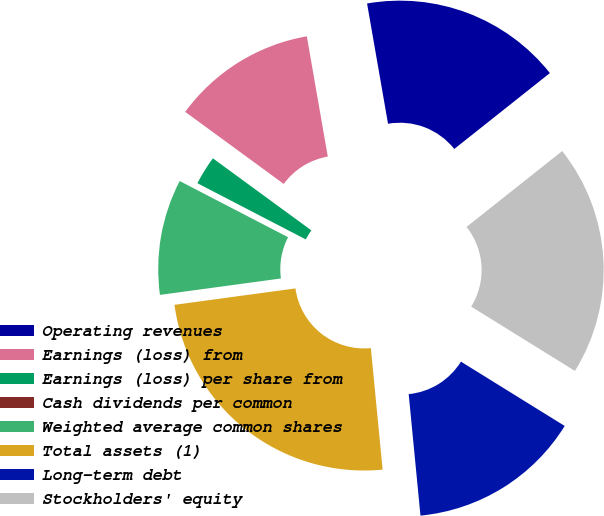Convert chart to OTSL. <chart><loc_0><loc_0><loc_500><loc_500><pie_chart><fcel>Operating revenues<fcel>Earnings (loss) from<fcel>Earnings (loss) per share from<fcel>Cash dividends per common<fcel>Weighted average common shares<fcel>Total assets (1)<fcel>Long-term debt<fcel>Stockholders' equity<nl><fcel>17.07%<fcel>12.2%<fcel>2.44%<fcel>0.0%<fcel>9.76%<fcel>24.39%<fcel>14.63%<fcel>19.51%<nl></chart> 